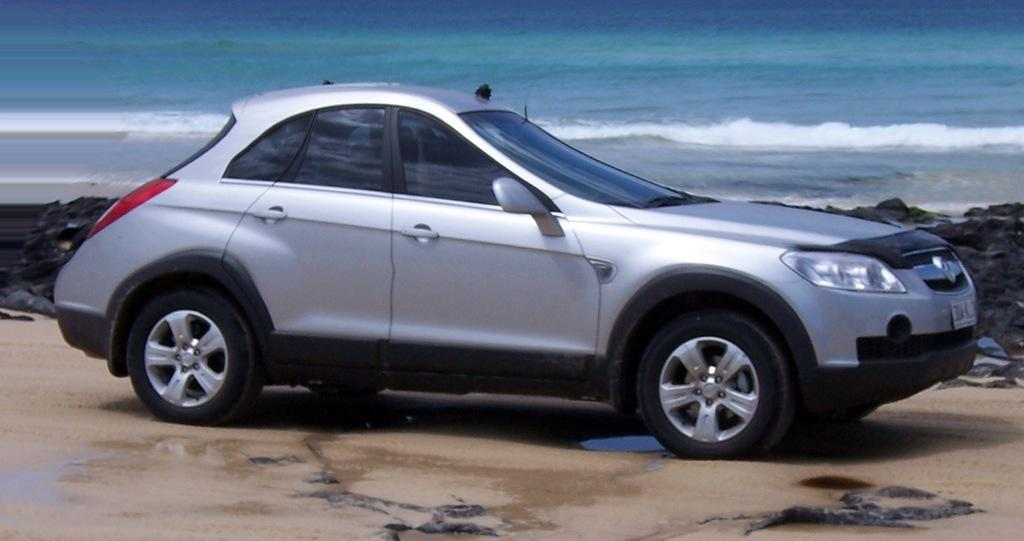What is the main subject of the image? There is a car in the image. Can you describe the background of the image? There is water visible in the background of the image. What type of stocking is hanging near the car in the image? There is no stocking present in the image. Can you tell me where the news is coming from in the image? There is no news source or any indication of news in the image. 